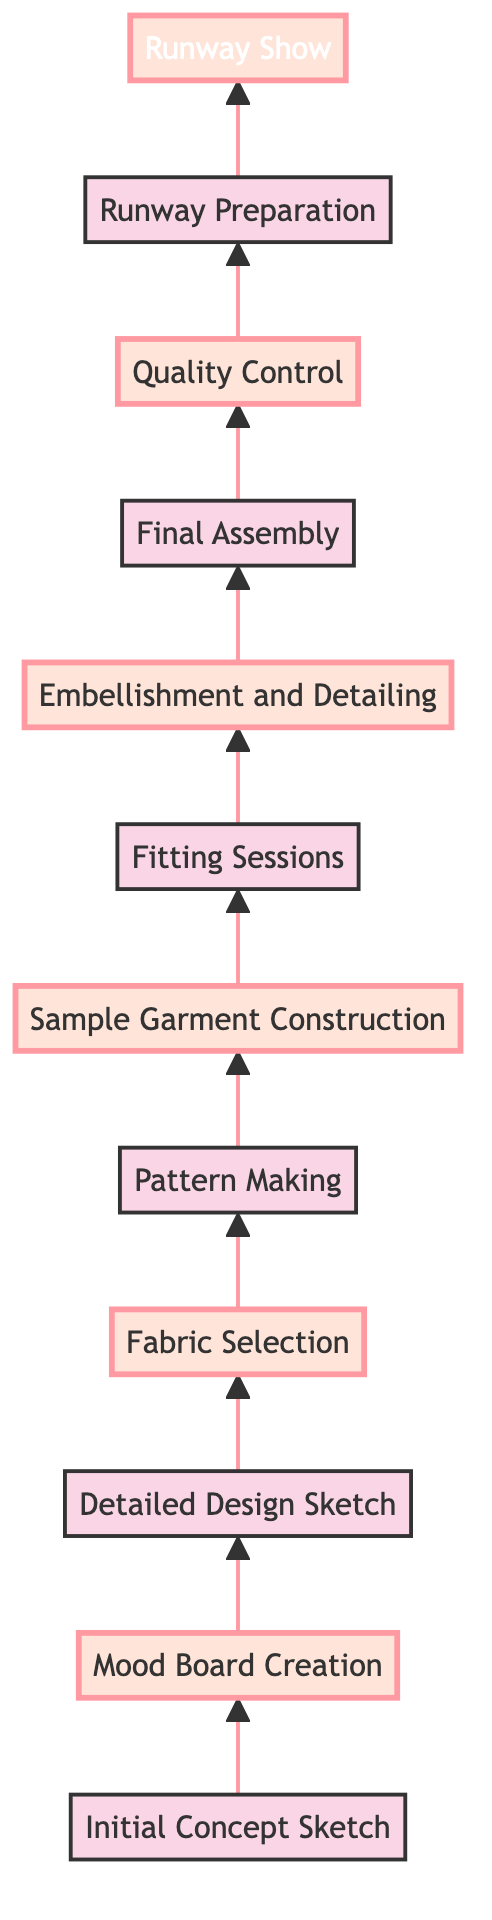What is the starting point of the design process? The starting point is represented as the first node in the diagram, which is "Initial Concept Sketch." This node is at the bottom of the flow chart and initiates the process.
Answer: Initial Concept Sketch What step comes directly after the Mood Board Creation? Following the "Mood Board Creation," the next step in the diagram is "Detailed Design Sketch." This can be determined by tracing the flow from the mood board node upwards.
Answer: Detailed Design Sketch How many total steps are in the process from concept to runway show? By counting the nodes in the diagram, including the starting and ending points, there are twelve steps in total. Each node represents a distinct phase in the design and production process.
Answer: 12 Which step involves the hand-application of intricate details? The step that focuses on hand-application of intricate details is "Embellishment and Detailing." This is specified as a key part of elevating the dress to couture standards.
Answer: Embellishment and Detailing What is the final step before the runway show? The last step before the "Runway Show" is "Runway Preparation." This step involves coordination with all participants to ensure the dress is perfectly showcased.
Answer: Runway Preparation What are the two highlighted steps that deal with fabric? The highlighted steps that specifically deal with fabric are "Fabric Selection" and "Sample Garment Construction." These phases focus on choosing the materials and constructing the initial sample garment.
Answer: Fabric Selection and Sample Garment Construction Which node represents the highest level of completion in the process? The "Runway Show" represents the highest level of completion as it is the final node in the diagram, showcasing the culmination of all prior efforts.
Answer: Runway Show What connects the Pattern Making step to Sample Garment Construction? The connection between "Pattern Making" and "Sample Garment Construction" is an upward arrow indicating that the completion of pattern making directly leads to the construction of the sample garment.
Answer: An upward arrow What is the primary focus of the Quality Control step? The primary focus of "Quality Control" is to conduct a thorough inspection for flaws and make any final adjustments to achieve haute couture standards.
Answer: Flaws and final adjustments 